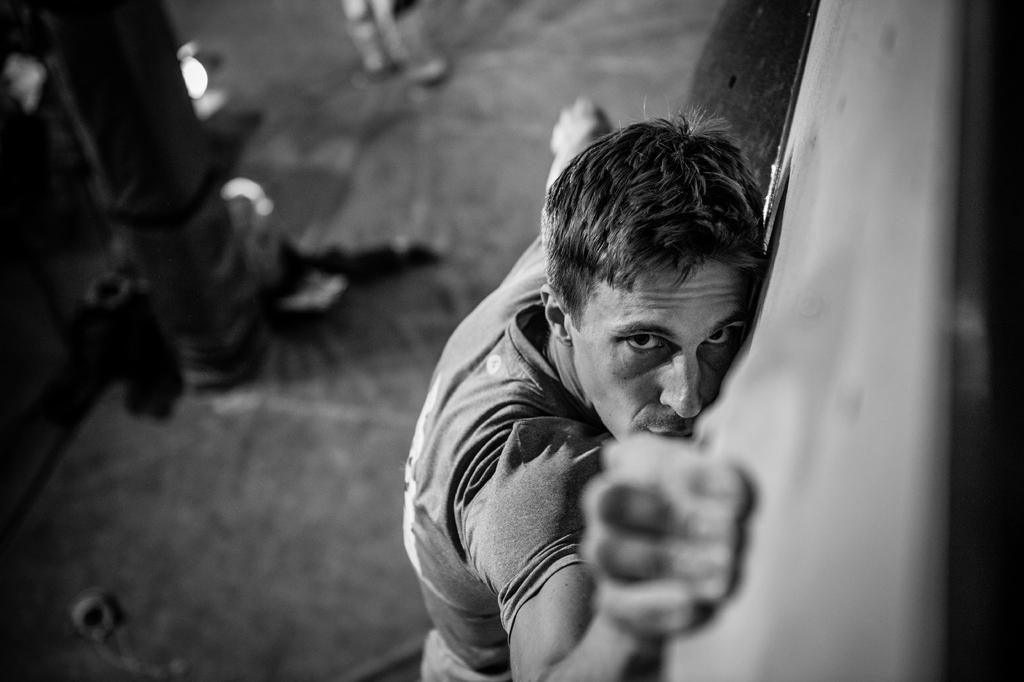What is the main subject of the image? There is a person standing in the center of the image. What can be seen in the background of the image? There is a pole and a few other objects in the background of the image. What type of dress is the person wearing in the image? The provided facts do not mention any dress or clothing details about the person in the image. --- Facts: 1. There is a car in the image. 2. The car is parked on the street. 3. There are trees on both sides of the street. 4. The sky is visible in the image. Absurd Topics: giraffe Conversation: What is the main subject of the image? There is a car in the image. Where is the car located? The car is parked on the street. What can be seen on both sides of the street? There are trees on both sides of the street. What is visible in the image? The sky is visible in the image. Reasoning: Let's think step by step in order to produce the conversation. We start by identifying the main subject of the image, which is the car. Next, we describe the location of the car, mentioning that it is parked on the street. Then, we observe the surroundings, noting that there are trees on both sides of the street. Finally, we describe the sky's visibility in the image. Absurd Question/Answer: How many giraffes can be seen in the image? There are no giraffes present in the image. 